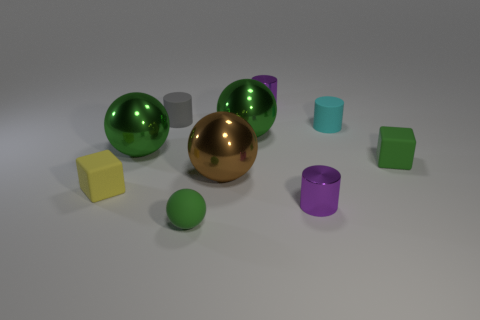Subtract all gray cylinders. How many cylinders are left? 3 Subtract all gray cylinders. How many green spheres are left? 3 Subtract all cyan cylinders. How many cylinders are left? 3 Subtract all brown spheres. Subtract all purple cubes. How many spheres are left? 3 Subtract all blocks. How many objects are left? 8 Subtract all small shiny objects. Subtract all tiny green spheres. How many objects are left? 7 Add 8 small yellow blocks. How many small yellow blocks are left? 9 Add 5 blue rubber cylinders. How many blue rubber cylinders exist? 5 Subtract 1 cyan cylinders. How many objects are left? 9 